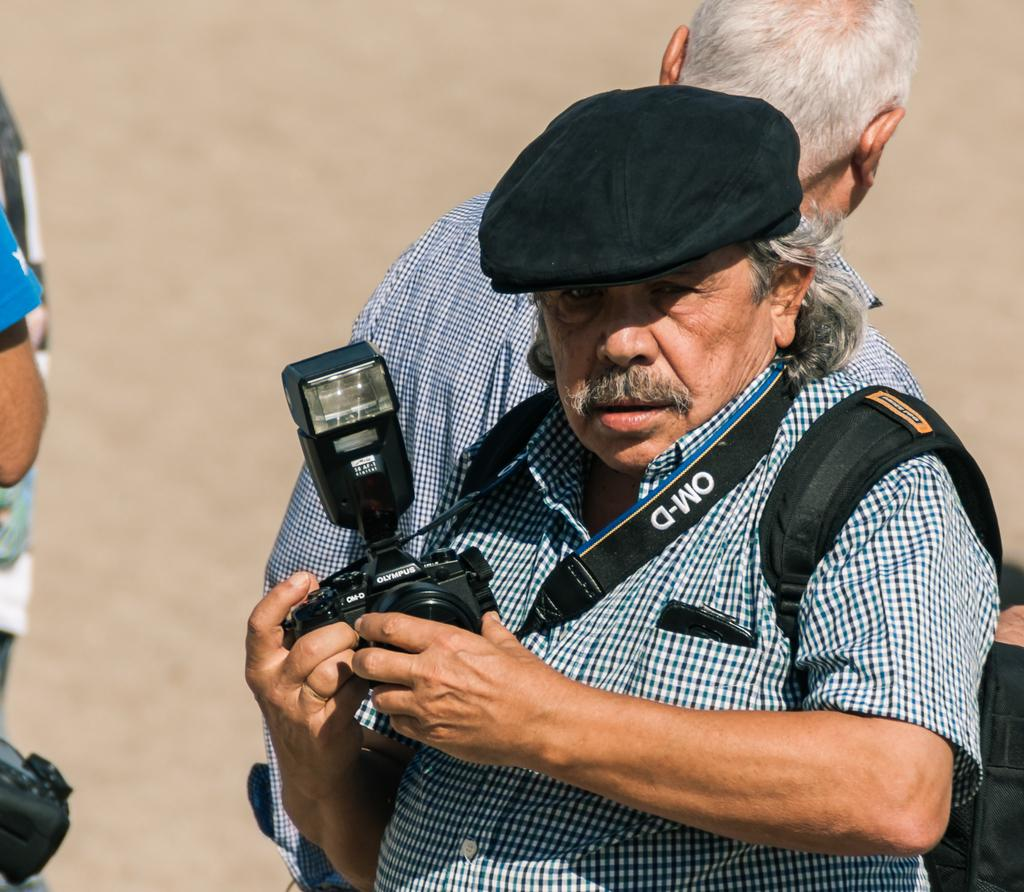Who is the main subject in the image? There is a person in the image. What is the person wearing? The person is wearing a backpack. What is the person holding in his hand? The person is holding a camera in his hand. Can you describe the background of the image? There is another person and ground visible in the background of the image. How many locks are visible on the person's backpack in the image? There are no locks visible on the person's backpack in the image. What type of land can be seen in the background of the image? There is no specific type of land mentioned in the image; only ground is visible in the background. 